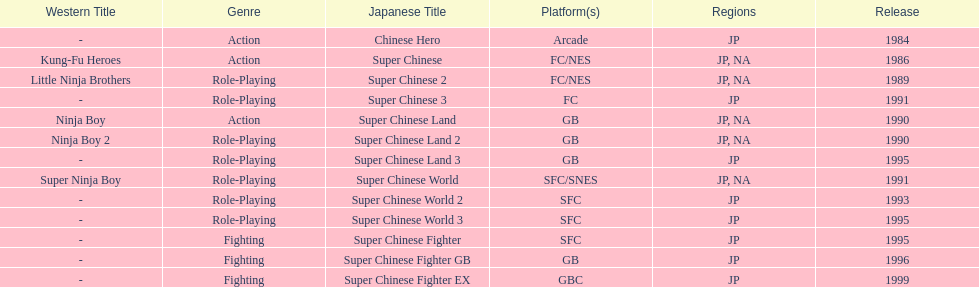How many super chinese games have been released in total? 13. 